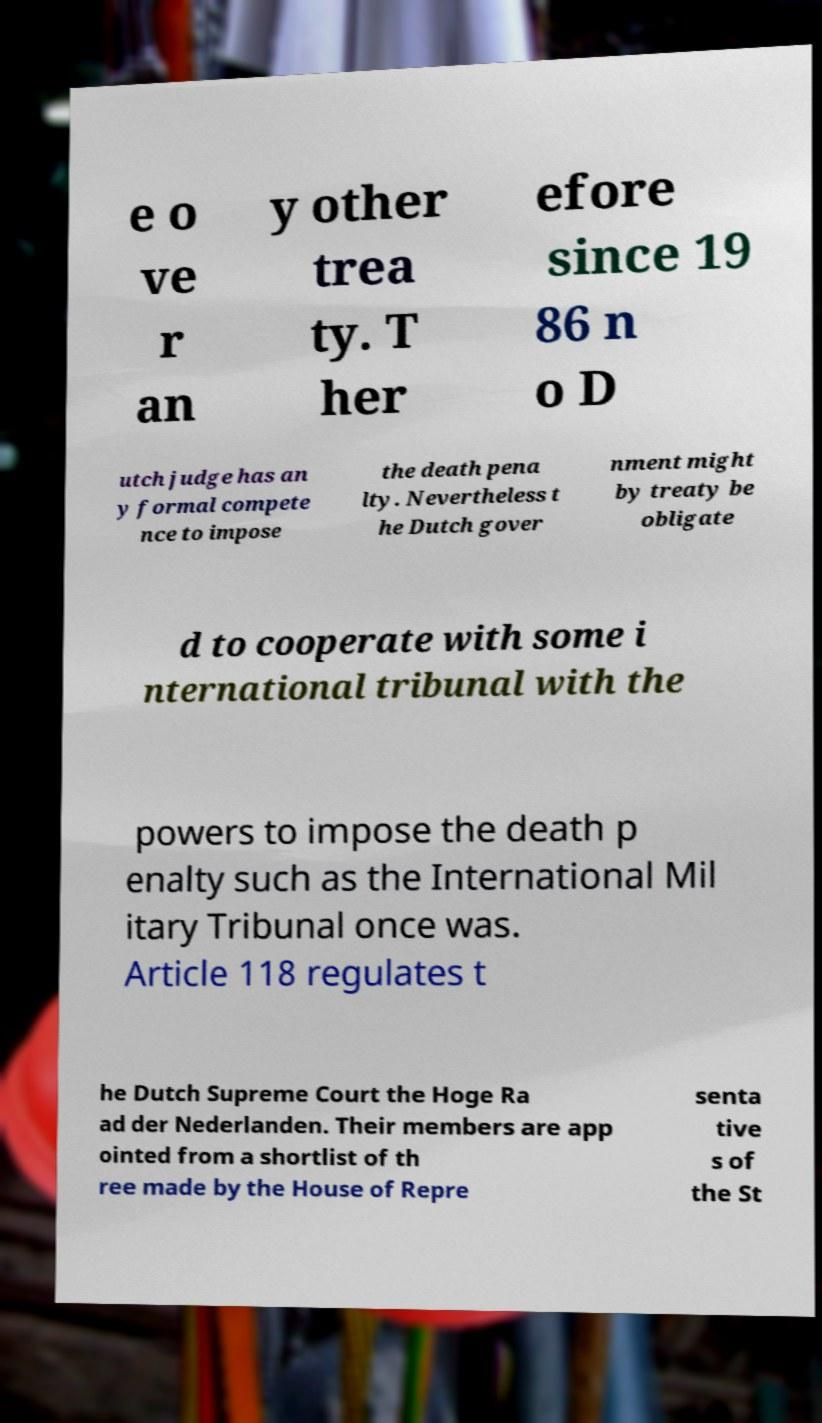For documentation purposes, I need the text within this image transcribed. Could you provide that? e o ve r an y other trea ty. T her efore since 19 86 n o D utch judge has an y formal compete nce to impose the death pena lty. Nevertheless t he Dutch gover nment might by treaty be obligate d to cooperate with some i nternational tribunal with the powers to impose the death p enalty such as the International Mil itary Tribunal once was. Article 118 regulates t he Dutch Supreme Court the Hoge Ra ad der Nederlanden. Their members are app ointed from a shortlist of th ree made by the House of Repre senta tive s of the St 